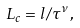Convert formula to latex. <formula><loc_0><loc_0><loc_500><loc_500>L _ { c } = l / \tau ^ { \nu } ,</formula> 